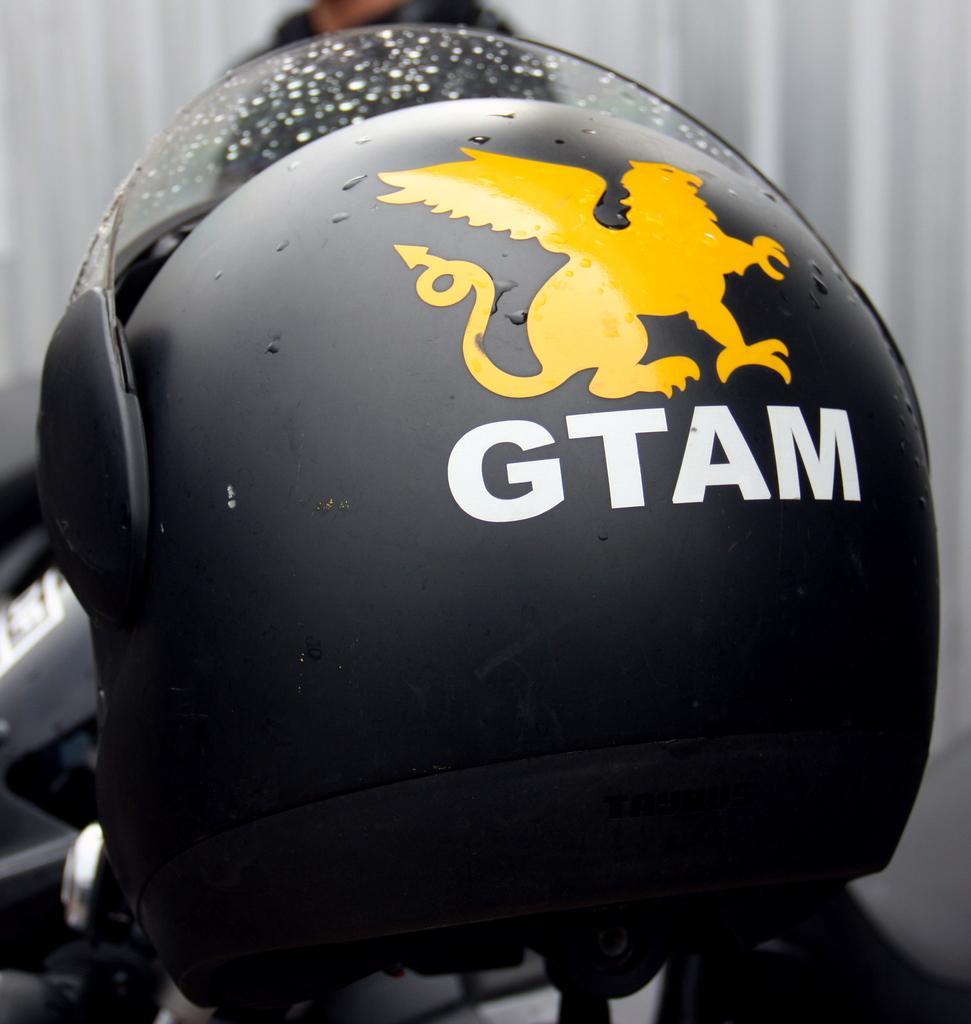Please provide a concise description of this image. There is a black color helmet with a white color text and a logo in the middle of this image, and it seems like there is one person standing at the top of this image, and there is a wall in the background. 